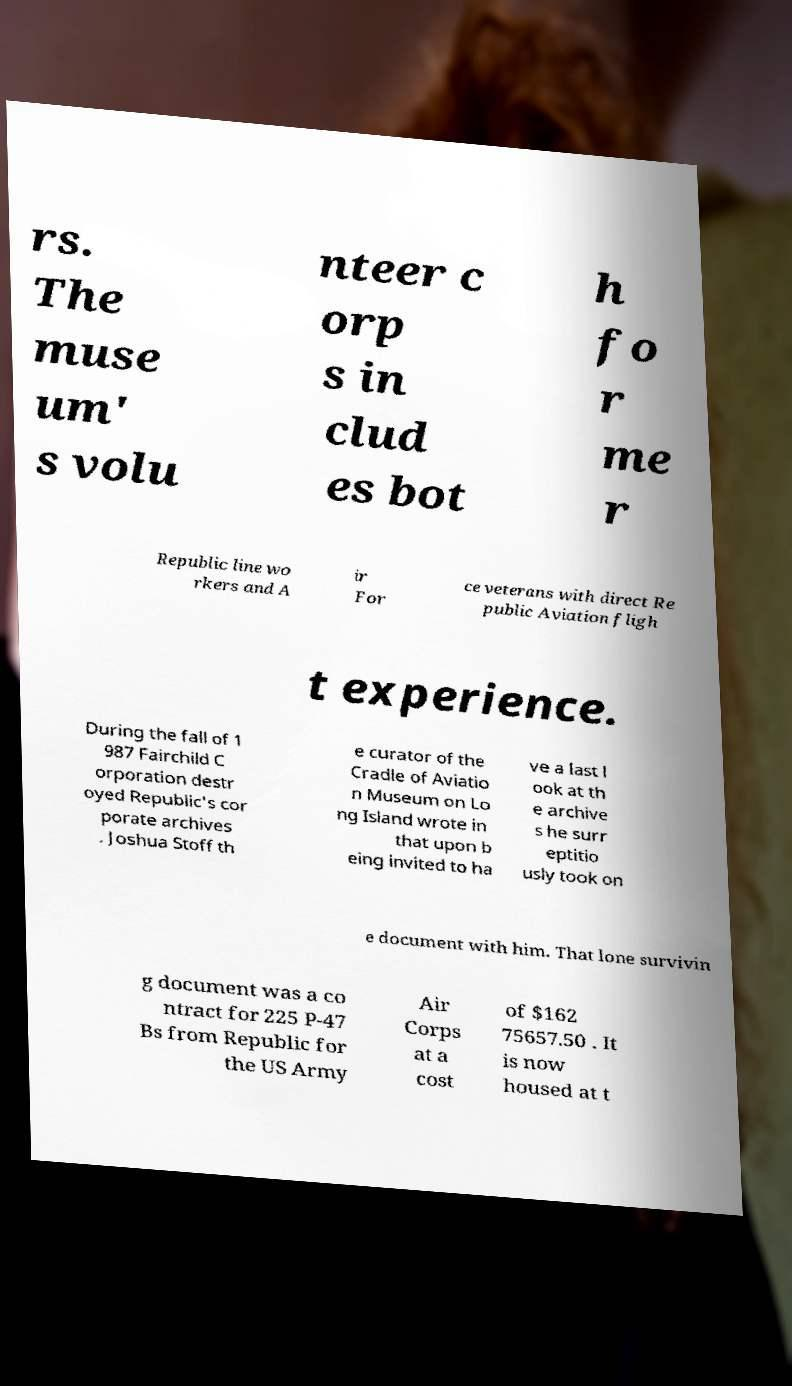Please identify and transcribe the text found in this image. rs. The muse um' s volu nteer c orp s in clud es bot h fo r me r Republic line wo rkers and A ir For ce veterans with direct Re public Aviation fligh t experience. During the fall of 1 987 Fairchild C orporation destr oyed Republic's cor porate archives . Joshua Stoff th e curator of the Cradle of Aviatio n Museum on Lo ng Island wrote in that upon b eing invited to ha ve a last l ook at th e archive s he surr eptitio usly took on e document with him. That lone survivin g document was a co ntract for 225 P-47 Bs from Republic for the US Army Air Corps at a cost of $162 75657.50 . It is now housed at t 